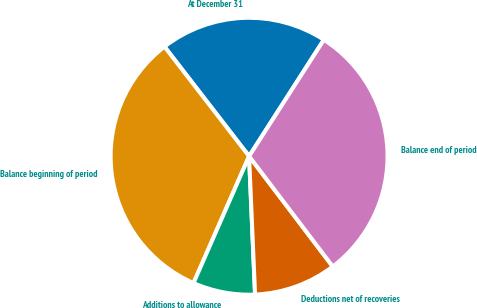<chart> <loc_0><loc_0><loc_500><loc_500><pie_chart><fcel>At December 31<fcel>Balance beginning of period<fcel>Additions to allowance<fcel>Deductions net of recoveries<fcel>Balance end of period<nl><fcel>19.55%<fcel>32.96%<fcel>7.26%<fcel>9.64%<fcel>30.58%<nl></chart> 